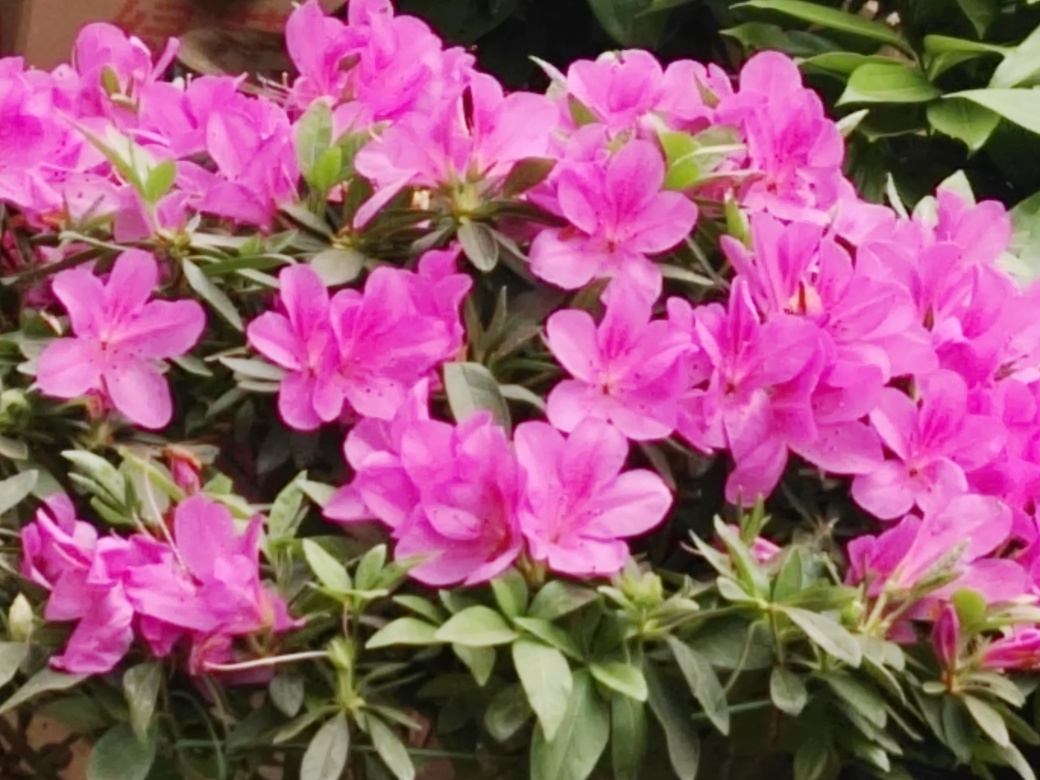Can you describe the flowers seen in the image? The image showcases a cluster of striking magenta-colored flowers, which seem to be azaleas. Each blossom has five petals and presents a luscious hue. They're surrounded by rich, green foliage, and their vibrant coloration suggests they are in full bloom, likely in a garden setting during spring or early summer. 